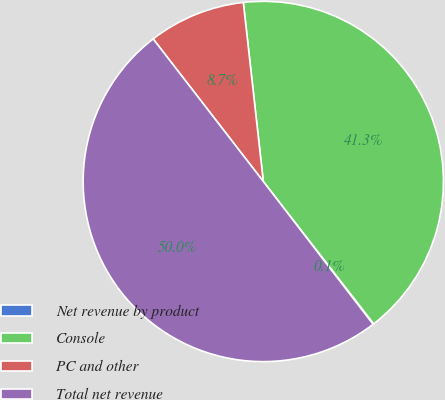<chart> <loc_0><loc_0><loc_500><loc_500><pie_chart><fcel>Net revenue by product<fcel>Console<fcel>PC and other<fcel>Total net revenue<nl><fcel>0.07%<fcel>41.27%<fcel>8.7%<fcel>49.96%<nl></chart> 